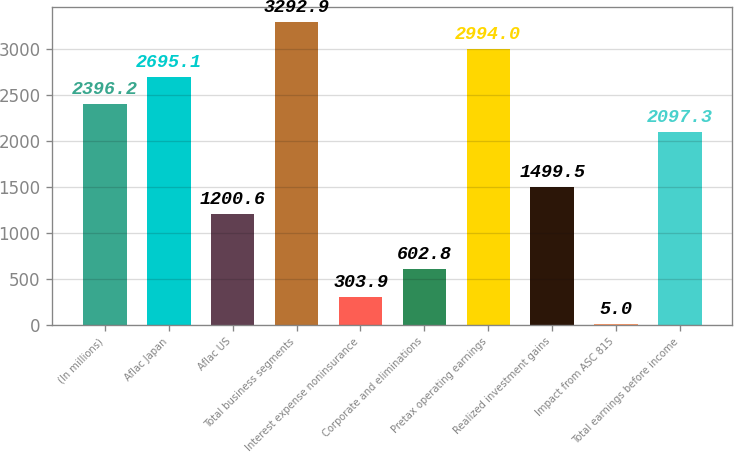Convert chart. <chart><loc_0><loc_0><loc_500><loc_500><bar_chart><fcel>(In millions)<fcel>Aflac Japan<fcel>Aflac US<fcel>Total business segments<fcel>Interest expense noninsurance<fcel>Corporate and eliminations<fcel>Pretax operating earnings<fcel>Realized investment gains<fcel>Impact from ASC 815<fcel>Total earnings before income<nl><fcel>2396.2<fcel>2695.1<fcel>1200.6<fcel>3292.9<fcel>303.9<fcel>602.8<fcel>2994<fcel>1499.5<fcel>5<fcel>2097.3<nl></chart> 